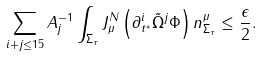<formula> <loc_0><loc_0><loc_500><loc_500>\sum _ { i + j \leq 1 5 } A _ { j } ^ { - 1 } \int _ { \Sigma _ { \tau } } J ^ { N } _ { \mu } \left ( \partial _ { t ^ { * } } ^ { i } \tilde { \Omega } ^ { j } \Phi \right ) n ^ { \mu } _ { \Sigma _ { \tau } } \leq \frac { \epsilon } { 2 } .</formula> 